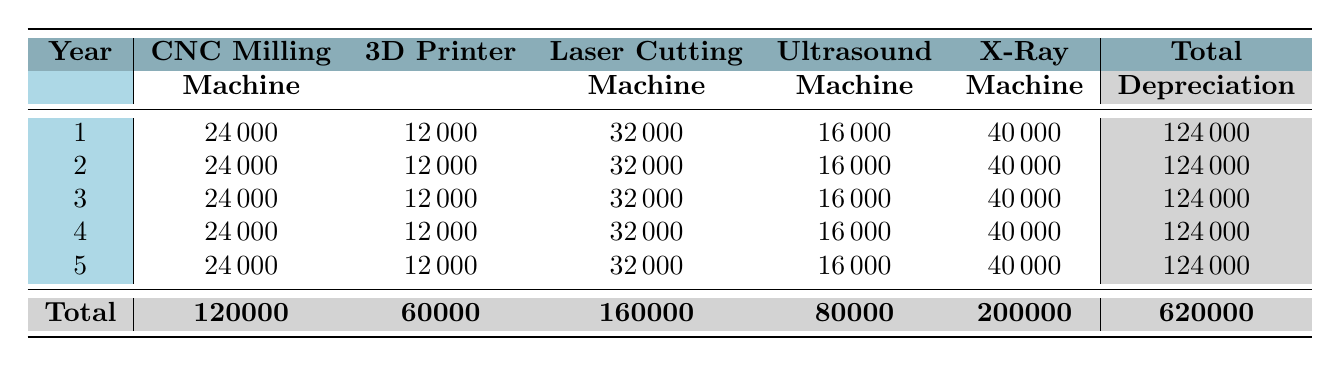What is the annual depreciation for the Ultrasound Machine? The Ultrasound Machine shows an annual depreciation value of 16000 in the table.
Answer: 16000 What is the total depreciation for the CNC Milling Machine over the 5 years? The table shows that each year the CNC Milling Machine depreciates by 24000. Over 5 years, this totals to 24000 multiplied by 5, which equals 120000.
Answer: 120000 Is the total annual depreciation the same for all 5 years? The total annual depreciation is consistently listed as 124000 for each of the 5 years in the table. Therefore, it is true that the total annual depreciation is the same each year.
Answer: Yes What is the combined depreciation for the Laser Cutting Machine and the X-Ray Machine over 5 years? The Laser Cutting Machine depreciates 32000 annually and the X-Ray Machine depreciates 40000 annually. Over 5 years, the Laser Cutting Machine totals 160000 and the X-Ray Machine totals 200000. Combining these gives us 160000 plus 200000, which equals 360000.
Answer: 360000 In which year does the Ultrasound Machine contribute the least to total depreciation? The Ultrasound Machine contributes 16000 to total depreciation every year, so it does not contribute less in any specific year; it remains constant. Therefore, there is no year when it contributes less.
Answer: No specific year What is the difference in total depreciation between the 3D Printer and the CNC Milling Machine over 5 years? The 3D Printer has a total depreciation of 60000 (12000 per year for 5 years) and the CNC Milling Machine has a total depreciation of 120000 (24000 per year for 5 years). The difference is calculated as 120000 minus 60000, which equals 60000.
Answer: 60000 Which machine has the highest total depreciation, and what is its value? Referring to the table, the X-Ray Machine has the highest annual depreciation of 40000 which totals to 200000 over 5 years, making it the highest.
Answer: X-Ray Machine, 200000 What is the average annual depreciation for all machines listed? The total depreciation for all machines over 5 years is summation of each machine's annual depreciation (24000 + 12000 + 32000 + 16000 + 40000 = 124000) multiplied by 5 gives 620000. To find the average, divide the total 620000 by the number of machines (5), resulting in 124000 divided by 5 equals 24800.
Answer: 24800 What is the total salvage value of all machines at the end of 5 years? The salvage values for each machine are: CNC Milling Machine (30000), 3D Printer (15000), Laser Cutting Machine (40000), Ultrasound Machine (20000), and X-Ray Machine (50000). Adding these values together results in 30000 + 15000 + 40000 + 20000 + 50000, which totals 155000.
Answer: 155000 